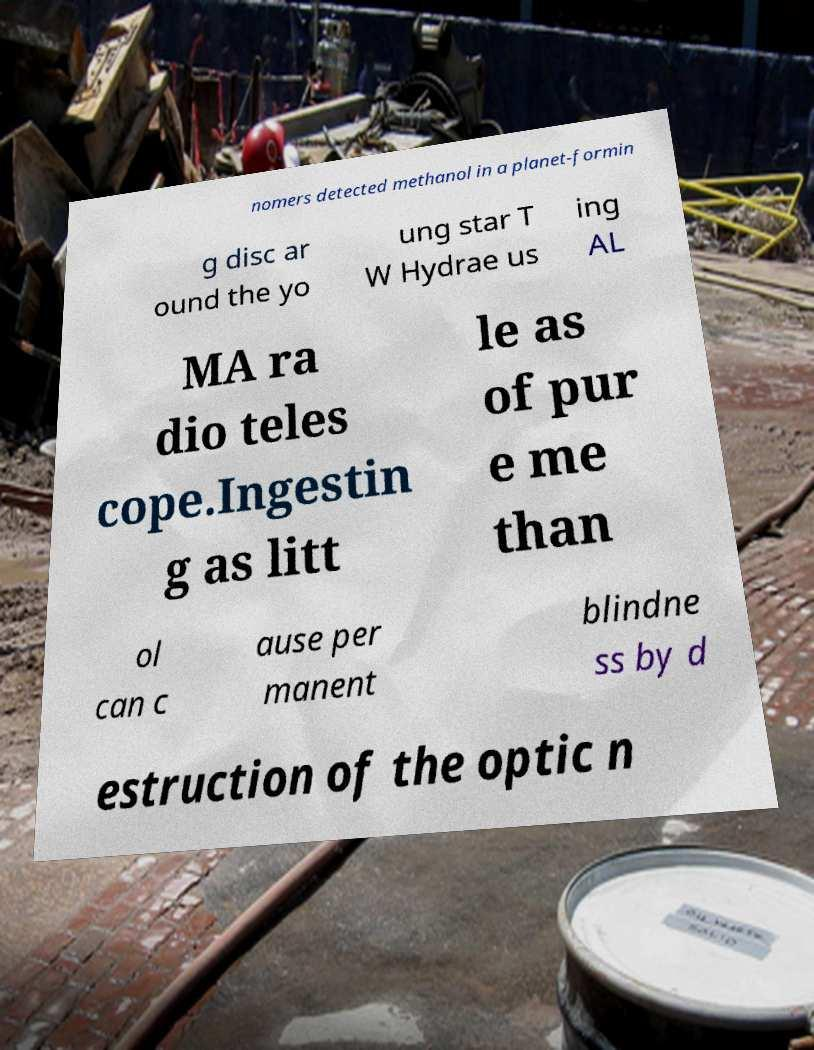Please identify and transcribe the text found in this image. nomers detected methanol in a planet-formin g disc ar ound the yo ung star T W Hydrae us ing AL MA ra dio teles cope.Ingestin g as litt le as of pur e me than ol can c ause per manent blindne ss by d estruction of the optic n 